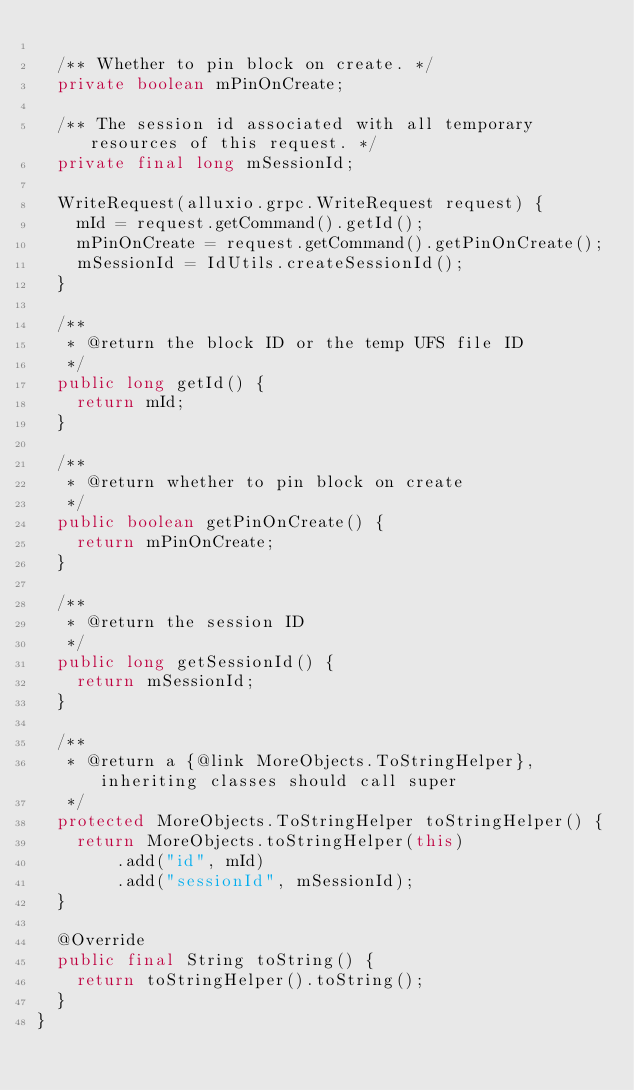<code> <loc_0><loc_0><loc_500><loc_500><_Java_>
  /** Whether to pin block on create. */
  private boolean mPinOnCreate;

  /** The session id associated with all temporary resources of this request. */
  private final long mSessionId;

  WriteRequest(alluxio.grpc.WriteRequest request) {
    mId = request.getCommand().getId();
    mPinOnCreate = request.getCommand().getPinOnCreate();
    mSessionId = IdUtils.createSessionId();
  }

  /**
   * @return the block ID or the temp UFS file ID
   */
  public long getId() {
    return mId;
  }

  /**
   * @return whether to pin block on create
   */
  public boolean getPinOnCreate() {
    return mPinOnCreate;
  }

  /**
   * @return the session ID
   */
  public long getSessionId() {
    return mSessionId;
  }

  /**
   * @return a {@link MoreObjects.ToStringHelper}, inheriting classes should call super
   */
  protected MoreObjects.ToStringHelper toStringHelper() {
    return MoreObjects.toStringHelper(this)
        .add("id", mId)
        .add("sessionId", mSessionId);
  }

  @Override
  public final String toString() {
    return toStringHelper().toString();
  }
}
</code> 